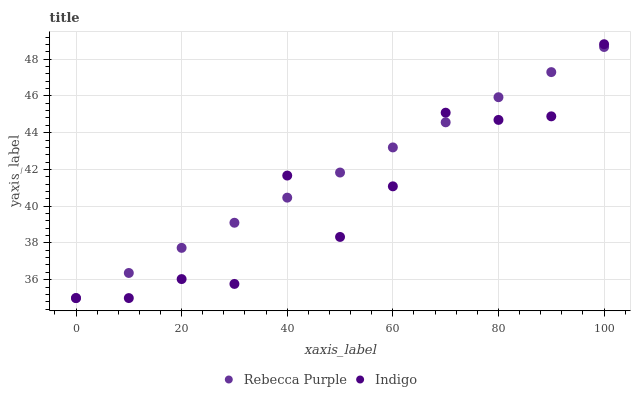Does Indigo have the minimum area under the curve?
Answer yes or no. Yes. Does Rebecca Purple have the maximum area under the curve?
Answer yes or no. Yes. Does Rebecca Purple have the minimum area under the curve?
Answer yes or no. No. Is Rebecca Purple the smoothest?
Answer yes or no. Yes. Is Indigo the roughest?
Answer yes or no. Yes. Is Rebecca Purple the roughest?
Answer yes or no. No. Does Indigo have the lowest value?
Answer yes or no. Yes. Does Indigo have the highest value?
Answer yes or no. Yes. Does Rebecca Purple have the highest value?
Answer yes or no. No. Does Indigo intersect Rebecca Purple?
Answer yes or no. Yes. Is Indigo less than Rebecca Purple?
Answer yes or no. No. Is Indigo greater than Rebecca Purple?
Answer yes or no. No. 